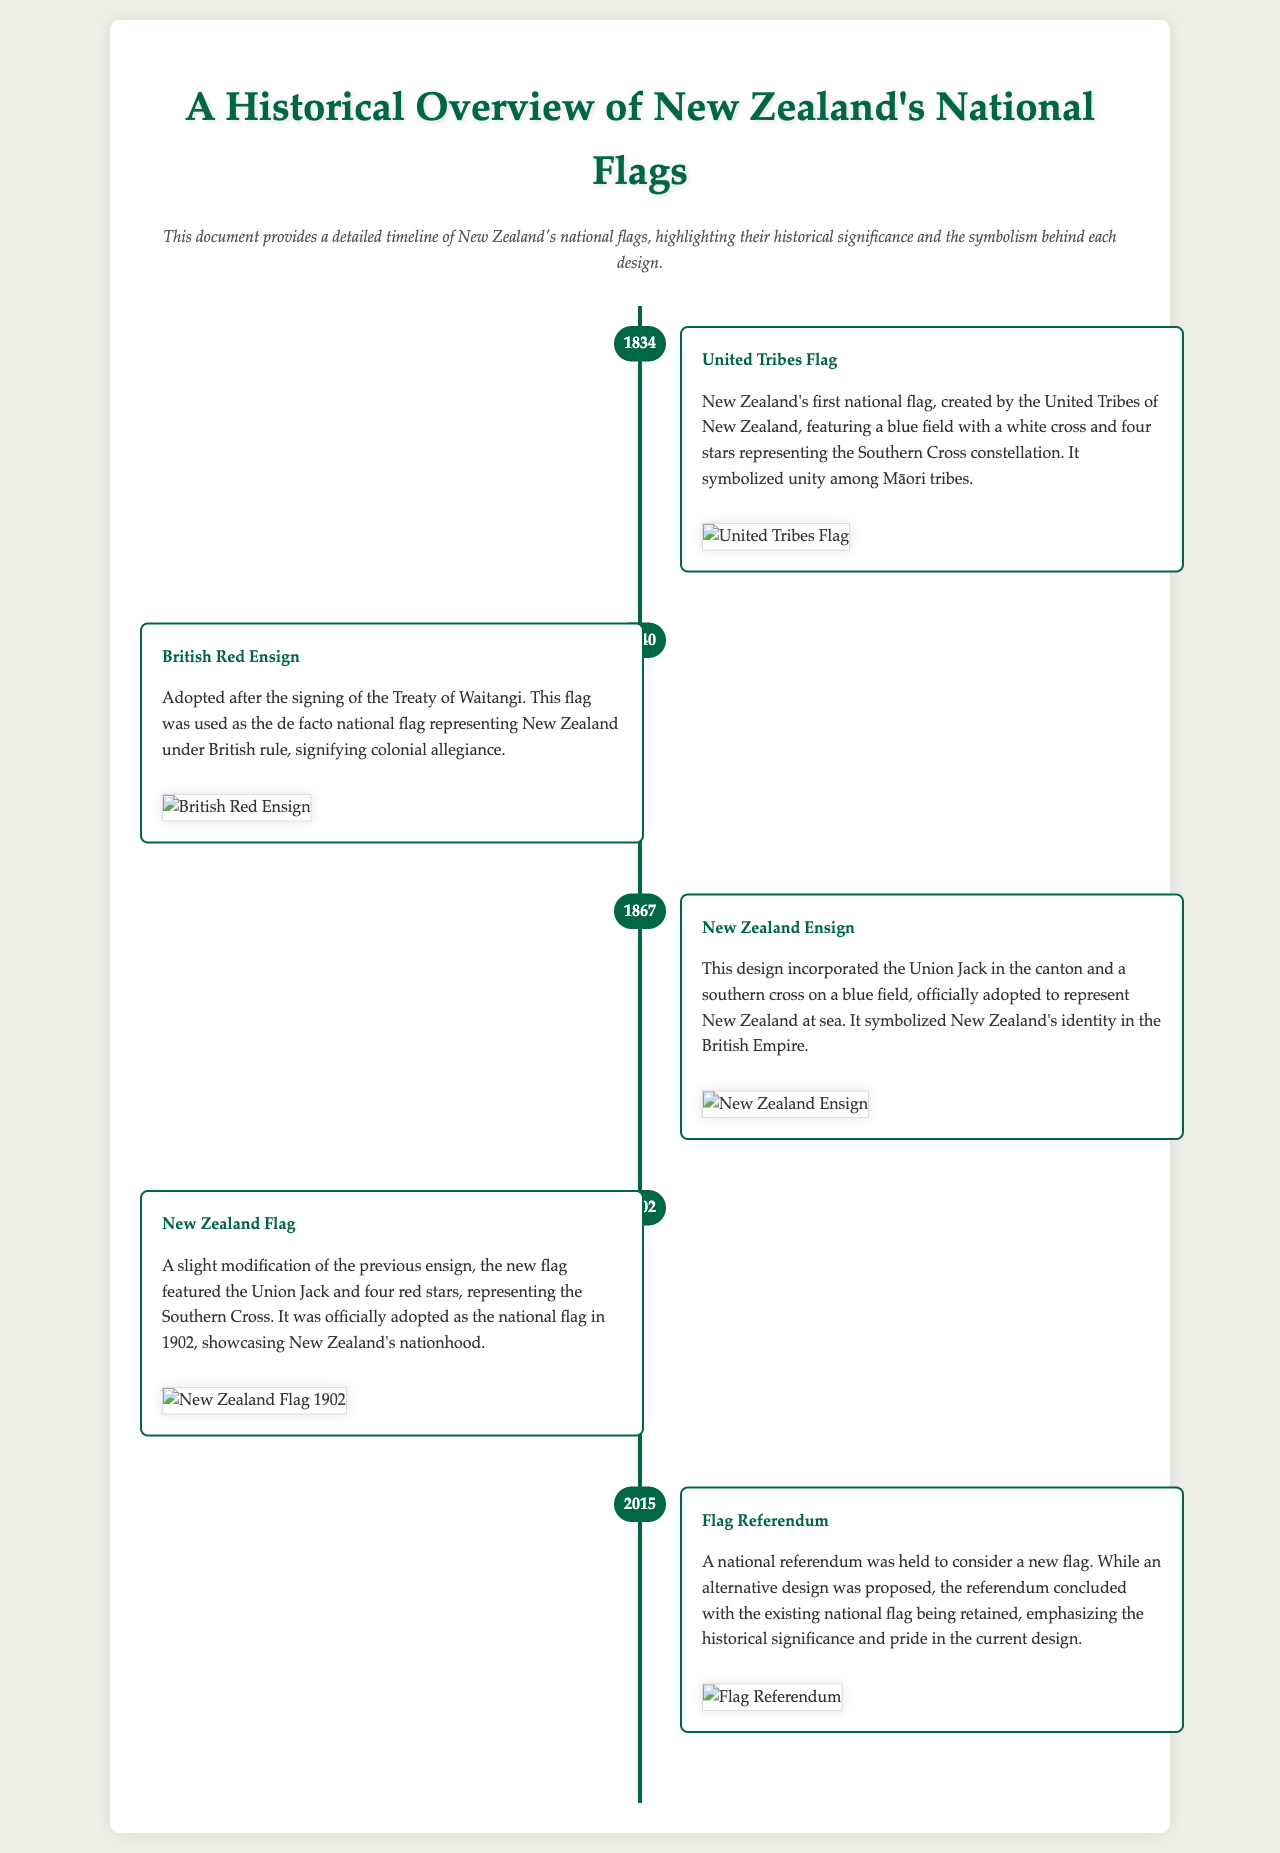what is the first national flag of New Zealand? The document states that the first national flag was created by the United Tribes of New Zealand.
Answer: United Tribes Flag in what year was the British Red Ensign adopted? The document specifies that the British Red Ensign was adopted in 1840 after the signing of the Treaty of Waitangi.
Answer: 1840 which flag features four red stars? According to the document, the New Zealand Flag adopted in 1902 features four red stars.
Answer: New Zealand Flag when was the Flag Referendum held? The document indicates that the Flag Referendum was held in 2015.
Answer: 2015 what does the Southern Cross represent in the United Tribes Flag? The document explains that the four stars in the United Tribes Flag represent the Southern Cross constellation.
Answer: unity among Māori tribes what was the purpose of the New Zealand Ensign? The document states that the New Zealand Ensign was officially adopted to represent New Zealand at sea.
Answer: represent New Zealand at sea how many items are in the timeline? The document lists a total of five timeline items covering different national flags.
Answer: five in which flag design is the Union Jack included? The document shows that both the New Zealand Ensign and the New Zealand Flag design incorporated the Union Jack.
Answer: New Zealand Ensign and New Zealand Flag 